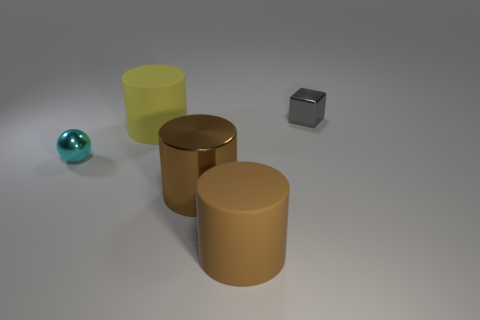Is the number of large brown metallic things less than the number of small green metal cylinders?
Ensure brevity in your answer.  No. What number of large objects are the same color as the metallic cylinder?
Give a very brief answer. 1. There is a big metallic object; does it have the same color as the large matte cylinder that is in front of the sphere?
Provide a succinct answer. Yes. Is the number of blue balls greater than the number of yellow objects?
Make the answer very short. No. Is the small cyan object made of the same material as the big thing behind the shiny sphere?
Make the answer very short. No. How many things are either tiny purple matte cubes or tiny cyan shiny things?
Your answer should be compact. 1. Do the matte cylinder that is in front of the small cyan metallic sphere and the metal object right of the large brown rubber thing have the same size?
Your response must be concise. No. How many blocks are large yellow objects or brown things?
Offer a terse response. 0. Are any gray cubes visible?
Offer a terse response. Yes. Are there any other things that are the same shape as the small gray thing?
Your response must be concise. No. 